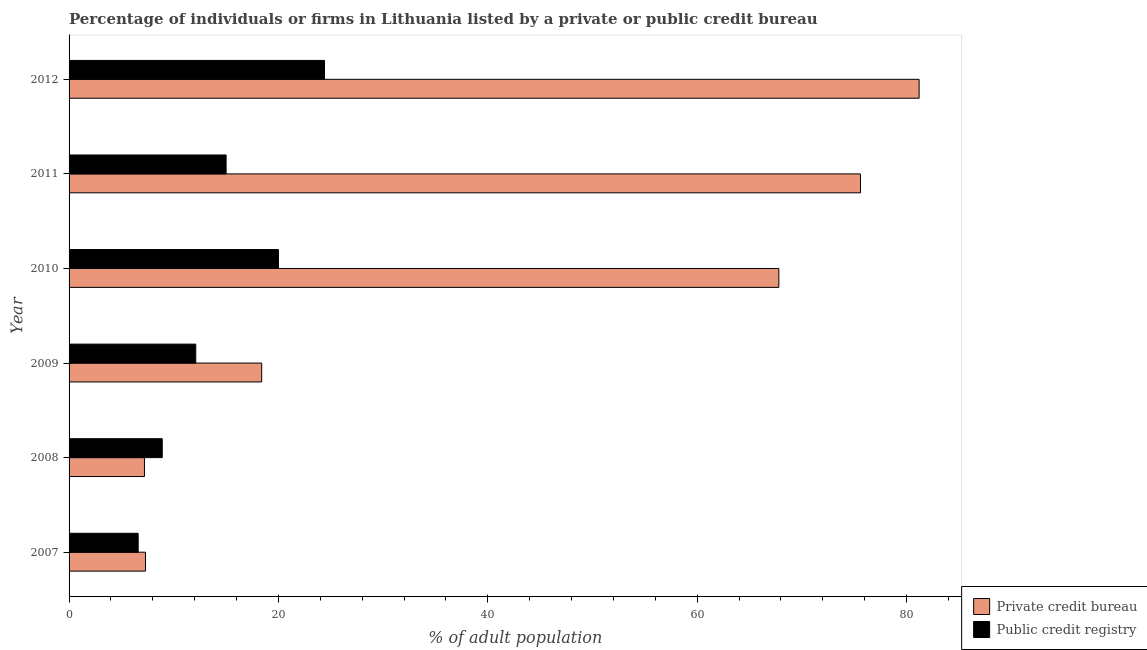How many different coloured bars are there?
Make the answer very short. 2. How many groups of bars are there?
Your response must be concise. 6. How many bars are there on the 6th tick from the top?
Provide a succinct answer. 2. Across all years, what is the maximum percentage of firms listed by private credit bureau?
Provide a short and direct response. 81.2. In which year was the percentage of firms listed by private credit bureau maximum?
Provide a succinct answer. 2012. In which year was the percentage of firms listed by private credit bureau minimum?
Ensure brevity in your answer.  2008. What is the difference between the percentage of firms listed by private credit bureau in 2008 and that in 2011?
Your answer should be compact. -68.4. What is the difference between the percentage of firms listed by private credit bureau in 2009 and the percentage of firms listed by public credit bureau in 2007?
Provide a succinct answer. 11.8. What is the average percentage of firms listed by private credit bureau per year?
Provide a succinct answer. 42.92. In the year 2010, what is the difference between the percentage of firms listed by public credit bureau and percentage of firms listed by private credit bureau?
Your answer should be very brief. -47.8. What is the ratio of the percentage of firms listed by private credit bureau in 2009 to that in 2010?
Make the answer very short. 0.27. Is the difference between the percentage of firms listed by private credit bureau in 2008 and 2010 greater than the difference between the percentage of firms listed by public credit bureau in 2008 and 2010?
Give a very brief answer. No. What is the difference between the highest and the second highest percentage of firms listed by public credit bureau?
Give a very brief answer. 4.4. What is the difference between the highest and the lowest percentage of firms listed by private credit bureau?
Provide a succinct answer. 74. Is the sum of the percentage of firms listed by private credit bureau in 2007 and 2012 greater than the maximum percentage of firms listed by public credit bureau across all years?
Give a very brief answer. Yes. What does the 2nd bar from the top in 2011 represents?
Ensure brevity in your answer.  Private credit bureau. What does the 2nd bar from the bottom in 2012 represents?
Your response must be concise. Public credit registry. Are all the bars in the graph horizontal?
Give a very brief answer. Yes. Are the values on the major ticks of X-axis written in scientific E-notation?
Ensure brevity in your answer.  No. What is the title of the graph?
Ensure brevity in your answer.  Percentage of individuals or firms in Lithuania listed by a private or public credit bureau. Does "2012 US$" appear as one of the legend labels in the graph?
Give a very brief answer. No. What is the label or title of the X-axis?
Your response must be concise. % of adult population. What is the % of adult population in Public credit registry in 2007?
Your answer should be very brief. 6.6. What is the % of adult population in Private credit bureau in 2009?
Ensure brevity in your answer.  18.4. What is the % of adult population in Public credit registry in 2009?
Your answer should be compact. 12.1. What is the % of adult population of Private credit bureau in 2010?
Offer a terse response. 67.8. What is the % of adult population of Public credit registry in 2010?
Your answer should be very brief. 20. What is the % of adult population in Private credit bureau in 2011?
Make the answer very short. 75.6. What is the % of adult population in Private credit bureau in 2012?
Provide a short and direct response. 81.2. What is the % of adult population in Public credit registry in 2012?
Ensure brevity in your answer.  24.4. Across all years, what is the maximum % of adult population of Private credit bureau?
Make the answer very short. 81.2. Across all years, what is the maximum % of adult population in Public credit registry?
Your answer should be very brief. 24.4. What is the total % of adult population of Private credit bureau in the graph?
Your answer should be very brief. 257.5. What is the difference between the % of adult population of Private credit bureau in 2007 and that in 2008?
Provide a short and direct response. 0.1. What is the difference between the % of adult population in Public credit registry in 2007 and that in 2008?
Provide a succinct answer. -2.3. What is the difference between the % of adult population in Private credit bureau in 2007 and that in 2009?
Provide a succinct answer. -11.1. What is the difference between the % of adult population in Private credit bureau in 2007 and that in 2010?
Make the answer very short. -60.5. What is the difference between the % of adult population in Public credit registry in 2007 and that in 2010?
Provide a succinct answer. -13.4. What is the difference between the % of adult population of Private credit bureau in 2007 and that in 2011?
Your response must be concise. -68.3. What is the difference between the % of adult population of Private credit bureau in 2007 and that in 2012?
Provide a short and direct response. -73.9. What is the difference between the % of adult population of Public credit registry in 2007 and that in 2012?
Provide a short and direct response. -17.8. What is the difference between the % of adult population in Private credit bureau in 2008 and that in 2009?
Offer a terse response. -11.2. What is the difference between the % of adult population of Public credit registry in 2008 and that in 2009?
Give a very brief answer. -3.2. What is the difference between the % of adult population in Private credit bureau in 2008 and that in 2010?
Your answer should be very brief. -60.6. What is the difference between the % of adult population of Private credit bureau in 2008 and that in 2011?
Offer a terse response. -68.4. What is the difference between the % of adult population in Private credit bureau in 2008 and that in 2012?
Provide a succinct answer. -74. What is the difference between the % of adult population of Public credit registry in 2008 and that in 2012?
Your answer should be compact. -15.5. What is the difference between the % of adult population of Private credit bureau in 2009 and that in 2010?
Your answer should be very brief. -49.4. What is the difference between the % of adult population of Private credit bureau in 2009 and that in 2011?
Ensure brevity in your answer.  -57.2. What is the difference between the % of adult population of Private credit bureau in 2009 and that in 2012?
Give a very brief answer. -62.8. What is the difference between the % of adult population in Public credit registry in 2009 and that in 2012?
Offer a very short reply. -12.3. What is the difference between the % of adult population of Private credit bureau in 2010 and that in 2011?
Your response must be concise. -7.8. What is the difference between the % of adult population in Public credit registry in 2010 and that in 2011?
Your answer should be compact. 5. What is the difference between the % of adult population in Public credit registry in 2010 and that in 2012?
Give a very brief answer. -4.4. What is the difference between the % of adult population in Private credit bureau in 2007 and the % of adult population in Public credit registry in 2008?
Make the answer very short. -1.6. What is the difference between the % of adult population in Private credit bureau in 2007 and the % of adult population in Public credit registry in 2009?
Your answer should be compact. -4.8. What is the difference between the % of adult population in Private credit bureau in 2007 and the % of adult population in Public credit registry in 2010?
Keep it short and to the point. -12.7. What is the difference between the % of adult population in Private credit bureau in 2007 and the % of adult population in Public credit registry in 2011?
Provide a short and direct response. -7.7. What is the difference between the % of adult population in Private credit bureau in 2007 and the % of adult population in Public credit registry in 2012?
Offer a very short reply. -17.1. What is the difference between the % of adult population in Private credit bureau in 2008 and the % of adult population in Public credit registry in 2011?
Ensure brevity in your answer.  -7.8. What is the difference between the % of adult population in Private credit bureau in 2008 and the % of adult population in Public credit registry in 2012?
Your answer should be compact. -17.2. What is the difference between the % of adult population in Private credit bureau in 2009 and the % of adult population in Public credit registry in 2010?
Provide a succinct answer. -1.6. What is the difference between the % of adult population of Private credit bureau in 2010 and the % of adult population of Public credit registry in 2011?
Offer a terse response. 52.8. What is the difference between the % of adult population in Private credit bureau in 2010 and the % of adult population in Public credit registry in 2012?
Offer a terse response. 43.4. What is the difference between the % of adult population in Private credit bureau in 2011 and the % of adult population in Public credit registry in 2012?
Keep it short and to the point. 51.2. What is the average % of adult population in Private credit bureau per year?
Your answer should be compact. 42.92. In the year 2008, what is the difference between the % of adult population of Private credit bureau and % of adult population of Public credit registry?
Keep it short and to the point. -1.7. In the year 2010, what is the difference between the % of adult population in Private credit bureau and % of adult population in Public credit registry?
Your answer should be compact. 47.8. In the year 2011, what is the difference between the % of adult population in Private credit bureau and % of adult population in Public credit registry?
Your answer should be compact. 60.6. In the year 2012, what is the difference between the % of adult population of Private credit bureau and % of adult population of Public credit registry?
Provide a succinct answer. 56.8. What is the ratio of the % of adult population in Private credit bureau in 2007 to that in 2008?
Make the answer very short. 1.01. What is the ratio of the % of adult population in Public credit registry in 2007 to that in 2008?
Offer a terse response. 0.74. What is the ratio of the % of adult population of Private credit bureau in 2007 to that in 2009?
Provide a short and direct response. 0.4. What is the ratio of the % of adult population in Public credit registry in 2007 to that in 2009?
Provide a succinct answer. 0.55. What is the ratio of the % of adult population in Private credit bureau in 2007 to that in 2010?
Provide a succinct answer. 0.11. What is the ratio of the % of adult population in Public credit registry in 2007 to that in 2010?
Keep it short and to the point. 0.33. What is the ratio of the % of adult population of Private credit bureau in 2007 to that in 2011?
Provide a succinct answer. 0.1. What is the ratio of the % of adult population in Public credit registry in 2007 to that in 2011?
Keep it short and to the point. 0.44. What is the ratio of the % of adult population in Private credit bureau in 2007 to that in 2012?
Your response must be concise. 0.09. What is the ratio of the % of adult population in Public credit registry in 2007 to that in 2012?
Your answer should be very brief. 0.27. What is the ratio of the % of adult population in Private credit bureau in 2008 to that in 2009?
Your answer should be compact. 0.39. What is the ratio of the % of adult population in Public credit registry in 2008 to that in 2009?
Your answer should be very brief. 0.74. What is the ratio of the % of adult population in Private credit bureau in 2008 to that in 2010?
Keep it short and to the point. 0.11. What is the ratio of the % of adult population in Public credit registry in 2008 to that in 2010?
Offer a terse response. 0.45. What is the ratio of the % of adult population of Private credit bureau in 2008 to that in 2011?
Make the answer very short. 0.1. What is the ratio of the % of adult population of Public credit registry in 2008 to that in 2011?
Keep it short and to the point. 0.59. What is the ratio of the % of adult population of Private credit bureau in 2008 to that in 2012?
Make the answer very short. 0.09. What is the ratio of the % of adult population in Public credit registry in 2008 to that in 2012?
Your answer should be very brief. 0.36. What is the ratio of the % of adult population in Private credit bureau in 2009 to that in 2010?
Ensure brevity in your answer.  0.27. What is the ratio of the % of adult population in Public credit registry in 2009 to that in 2010?
Offer a very short reply. 0.6. What is the ratio of the % of adult population in Private credit bureau in 2009 to that in 2011?
Make the answer very short. 0.24. What is the ratio of the % of adult population of Public credit registry in 2009 to that in 2011?
Offer a very short reply. 0.81. What is the ratio of the % of adult population of Private credit bureau in 2009 to that in 2012?
Give a very brief answer. 0.23. What is the ratio of the % of adult population in Public credit registry in 2009 to that in 2012?
Offer a terse response. 0.5. What is the ratio of the % of adult population in Private credit bureau in 2010 to that in 2011?
Provide a succinct answer. 0.9. What is the ratio of the % of adult population in Private credit bureau in 2010 to that in 2012?
Make the answer very short. 0.83. What is the ratio of the % of adult population of Public credit registry in 2010 to that in 2012?
Keep it short and to the point. 0.82. What is the ratio of the % of adult population of Public credit registry in 2011 to that in 2012?
Provide a short and direct response. 0.61. 